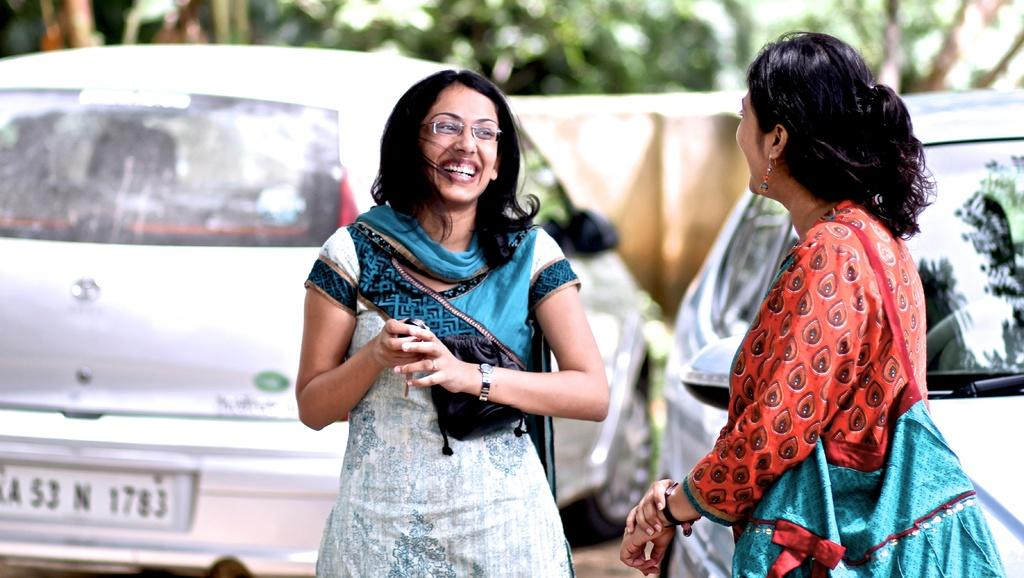How many women are in the foreground of the picture? There are two women standing in the foreground of the picture. What can be observed about the background of the image? The background of the image is blurred. What types of vehicles can be seen in the background of the image? There are cars in the background of the image. What other natural elements are present in the background of the image? There are trees in the background of the image. What else can be seen in the background of the image? There are other objects in the background of the image. What songs are being sung by the women in the image? There is no indication in the image that the women are singing songs, so it cannot be determined from the picture. 